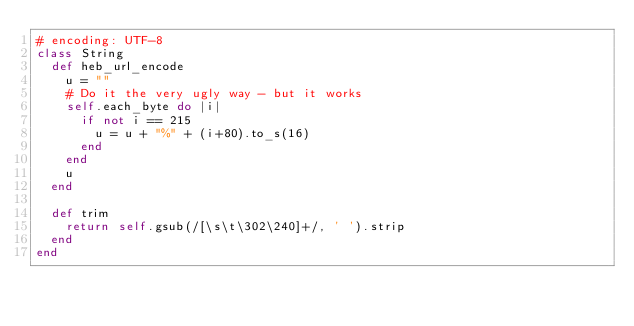<code> <loc_0><loc_0><loc_500><loc_500><_Ruby_># encoding: UTF-8
class String
  def heb_url_encode
    u = ""
    # Do it the very ugly way - but it works
    self.each_byte do |i|
      if not i == 215
        u = u + "%" + (i+80).to_s(16)
      end
    end
    u
  end

  def trim
    return self.gsub(/[\s\t\302\240]+/, ' ').strip
  end
end
</code> 